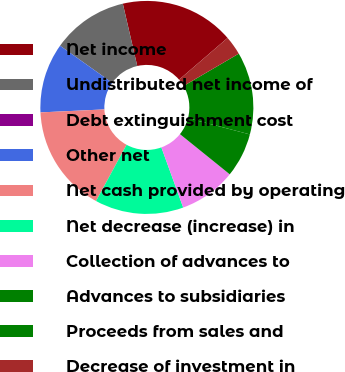Convert chart. <chart><loc_0><loc_0><loc_500><loc_500><pie_chart><fcel>Net income<fcel>Undistributed net income of<fcel>Debt extinguishment cost<fcel>Other net<fcel>Net cash provided by operating<fcel>Net decrease (increase) in<fcel>Collection of advances to<fcel>Advances to subsidiaries<fcel>Proceeds from sales and<fcel>Decrease of investment in<nl><fcel>17.31%<fcel>11.54%<fcel>0.0%<fcel>10.58%<fcel>16.34%<fcel>13.46%<fcel>8.65%<fcel>6.73%<fcel>12.5%<fcel>2.89%<nl></chart> 